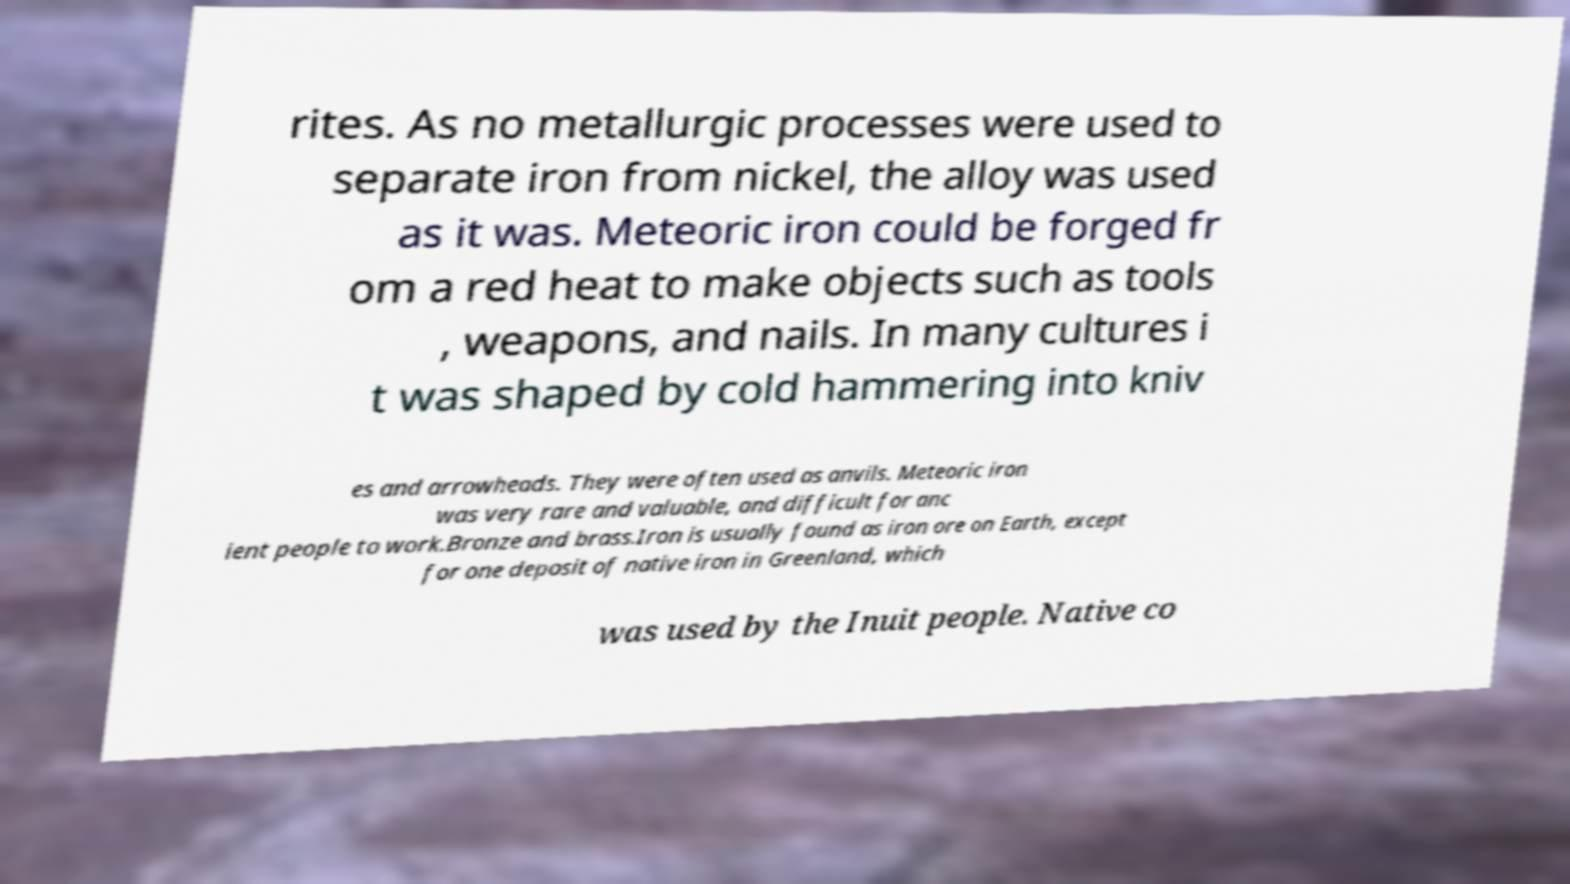Please identify and transcribe the text found in this image. rites. As no metallurgic processes were used to separate iron from nickel, the alloy was used as it was. Meteoric iron could be forged fr om a red heat to make objects such as tools , weapons, and nails. In many cultures i t was shaped by cold hammering into kniv es and arrowheads. They were often used as anvils. Meteoric iron was very rare and valuable, and difficult for anc ient people to work.Bronze and brass.Iron is usually found as iron ore on Earth, except for one deposit of native iron in Greenland, which was used by the Inuit people. Native co 